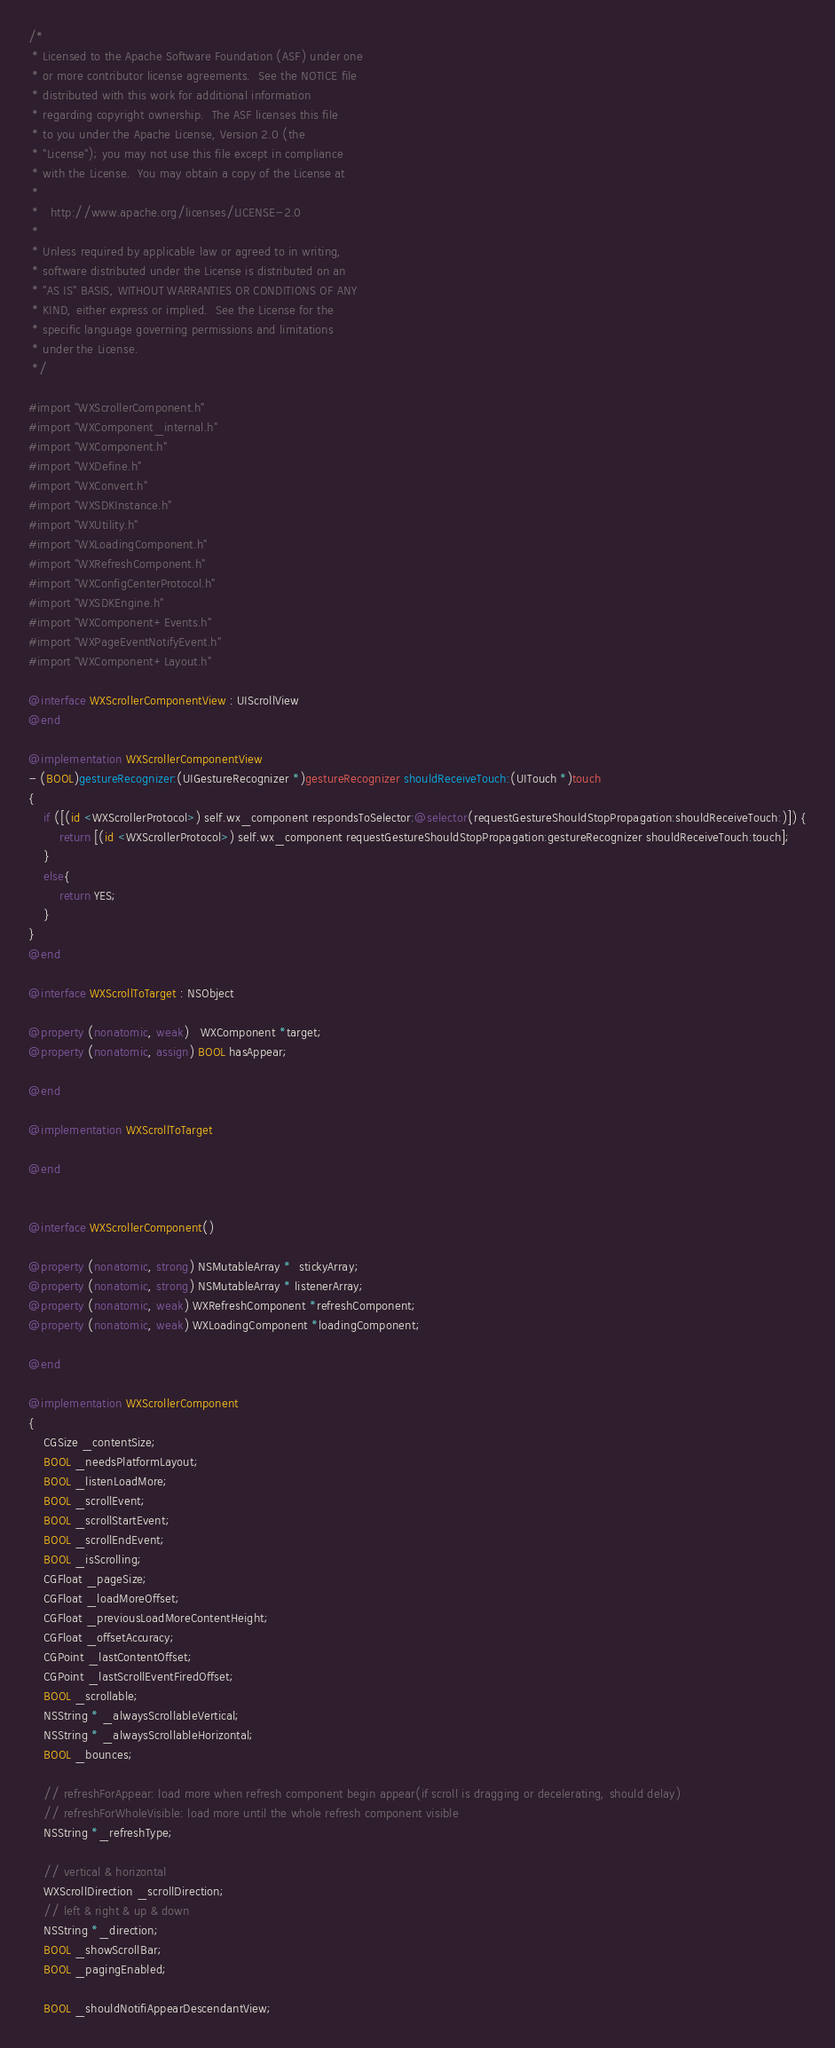<code> <loc_0><loc_0><loc_500><loc_500><_ObjectiveC_>/*
 * Licensed to the Apache Software Foundation (ASF) under one
 * or more contributor license agreements.  See the NOTICE file
 * distributed with this work for additional information
 * regarding copyright ownership.  The ASF licenses this file
 * to you under the Apache License, Version 2.0 (the
 * "License"); you may not use this file except in compliance
 * with the License.  You may obtain a copy of the License at
 *
 *   http://www.apache.org/licenses/LICENSE-2.0
 *
 * Unless required by applicable law or agreed to in writing,
 * software distributed under the License is distributed on an
 * "AS IS" BASIS, WITHOUT WARRANTIES OR CONDITIONS OF ANY
 * KIND, either express or implied.  See the License for the
 * specific language governing permissions and limitations
 * under the License.
 */

#import "WXScrollerComponent.h"
#import "WXComponent_internal.h"
#import "WXComponent.h"
#import "WXDefine.h"
#import "WXConvert.h"
#import "WXSDKInstance.h"
#import "WXUtility.h"
#import "WXLoadingComponent.h"
#import "WXRefreshComponent.h"
#import "WXConfigCenterProtocol.h"
#import "WXSDKEngine.h"
#import "WXComponent+Events.h"
#import "WXPageEventNotifyEvent.h"
#import "WXComponent+Layout.h"

@interface WXScrollerComponentView : UIScrollView
@end

@implementation WXScrollerComponentView
- (BOOL)gestureRecognizer:(UIGestureRecognizer *)gestureRecognizer shouldReceiveTouch:(UITouch *)touch
{
    if ([(id <WXScrollerProtocol>) self.wx_component respondsToSelector:@selector(requestGestureShouldStopPropagation:shouldReceiveTouch:)]) {
        return [(id <WXScrollerProtocol>) self.wx_component requestGestureShouldStopPropagation:gestureRecognizer shouldReceiveTouch:touch];
    }
    else{
        return YES;
    }
}
@end

@interface WXScrollToTarget : NSObject

@property (nonatomic, weak)   WXComponent *target;
@property (nonatomic, assign) BOOL hasAppear;

@end

@implementation WXScrollToTarget

@end


@interface WXScrollerComponent()

@property (nonatomic, strong) NSMutableArray *  stickyArray;
@property (nonatomic, strong) NSMutableArray * listenerArray;
@property (nonatomic, weak) WXRefreshComponent *refreshComponent;
@property (nonatomic, weak) WXLoadingComponent *loadingComponent;

@end

@implementation WXScrollerComponent
{
    CGSize _contentSize;
    BOOL _needsPlatformLayout;
    BOOL _listenLoadMore;
    BOOL _scrollEvent;
    BOOL _scrollStartEvent;
    BOOL _scrollEndEvent;
    BOOL _isScrolling;
    CGFloat _pageSize;
    CGFloat _loadMoreOffset;
    CGFloat _previousLoadMoreContentHeight;
    CGFloat _offsetAccuracy;
    CGPoint _lastContentOffset;
    CGPoint _lastScrollEventFiredOffset;
    BOOL _scrollable;
    NSString * _alwaysScrollableVertical;
    NSString * _alwaysScrollableHorizontal;
    BOOL _bounces;
    
    // refreshForAppear: load more when refresh component begin appear(if scroll is dragging or decelerating, should delay)
    // refreshForWholeVisible: load more until the whole refresh component visible
    NSString *_refreshType;

    // vertical & horizontal
    WXScrollDirection _scrollDirection;
    // left & right & up & down
    NSString *_direction;
    BOOL _showScrollBar;
    BOOL _pagingEnabled;
    
    BOOL _shouldNotifiAppearDescendantView;</code> 